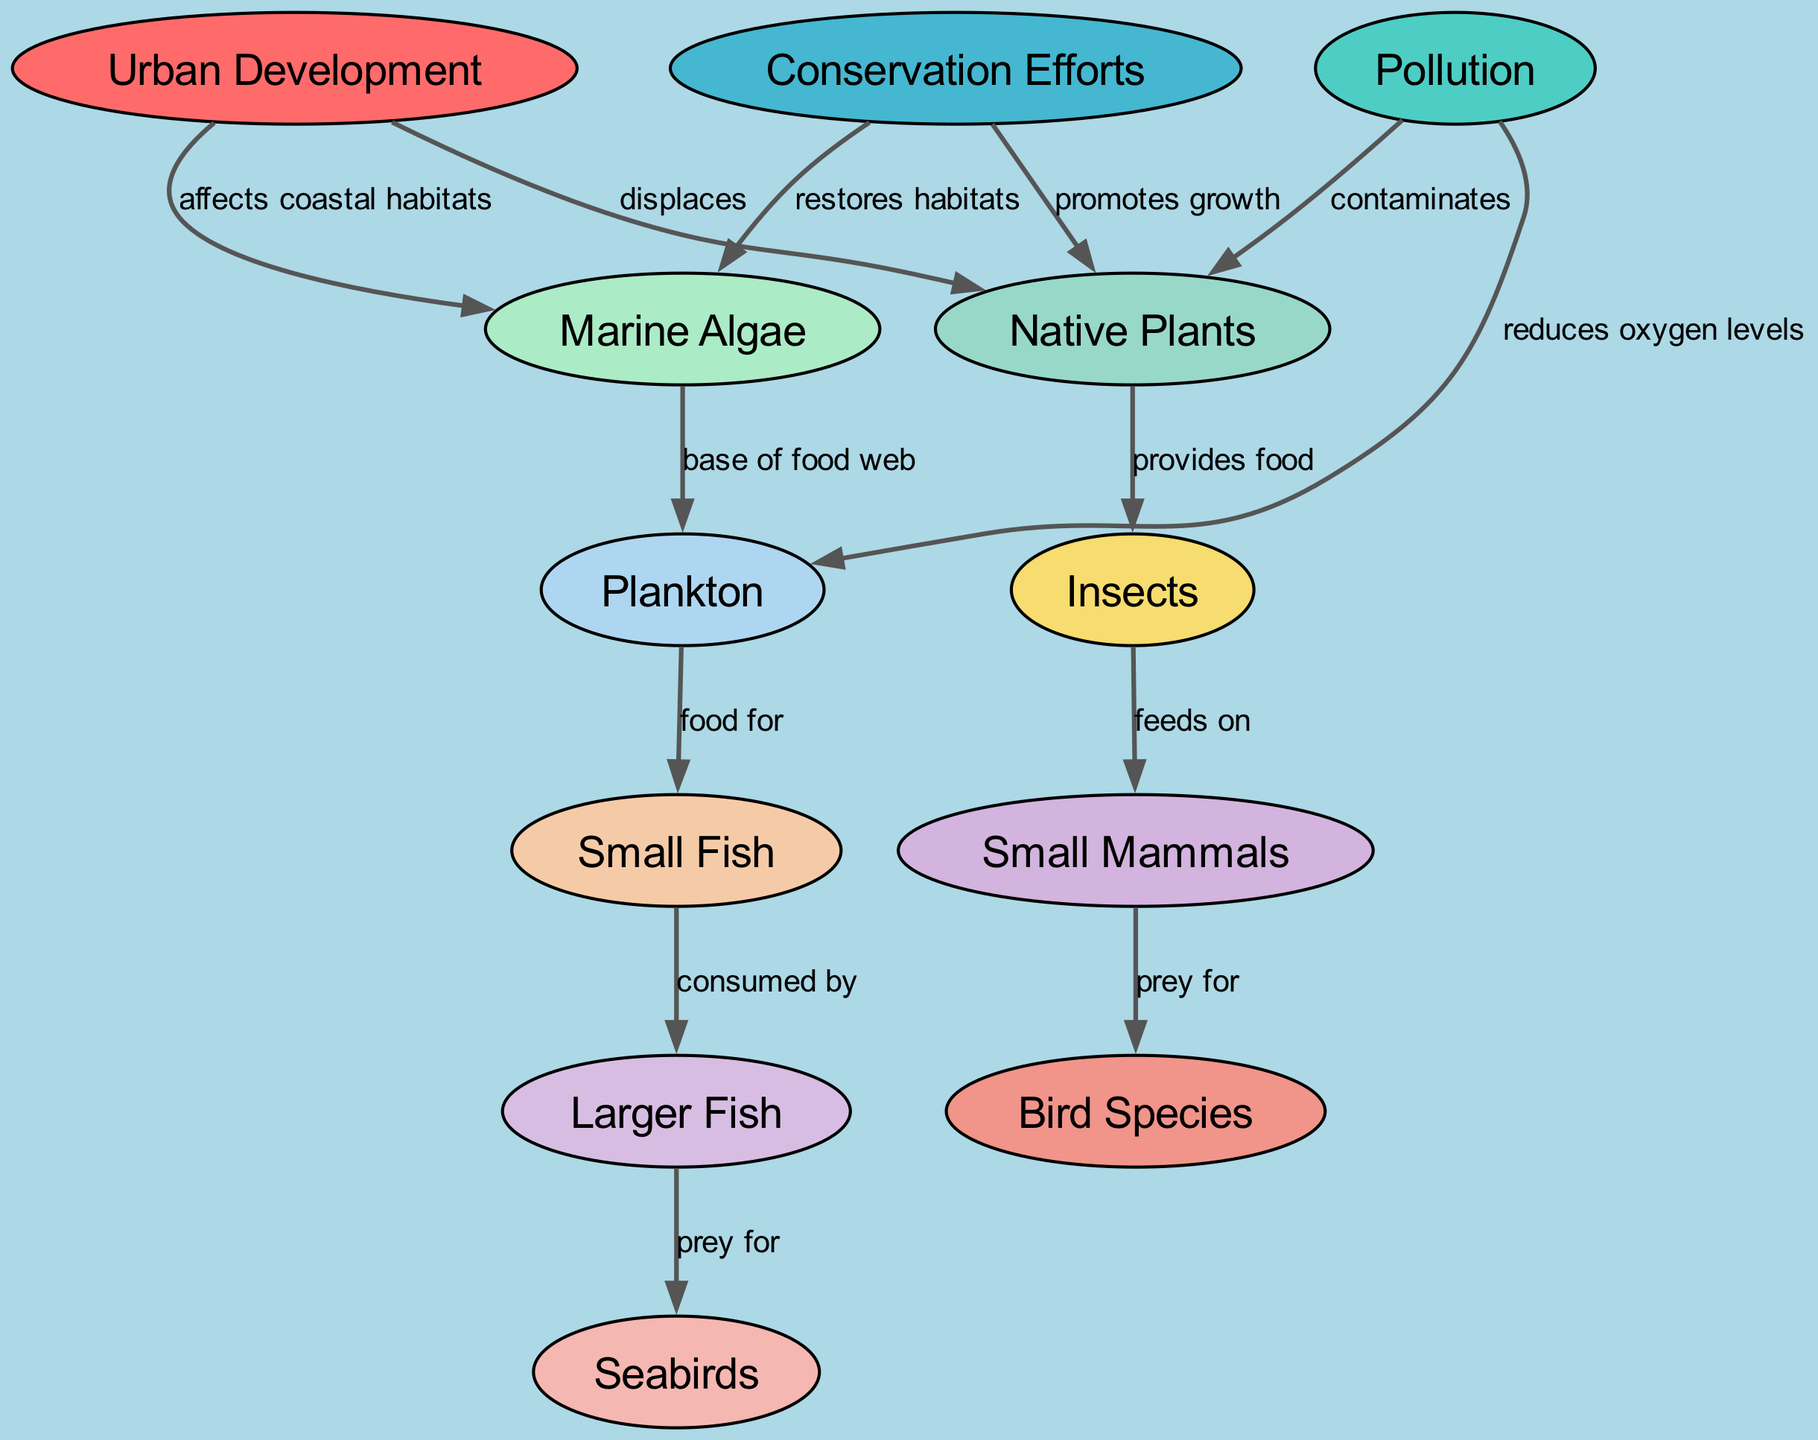What is the total number of nodes in the diagram? The diagram lists 12 nodes, which include Urban Development, Pollution, Conservation Efforts, Native Plants, Insects, Small Mammals, Bird Species, Marine Algae, Plankton, Small Fish, Larger Fish, and Seabirds.
Answer: 12 What effect does urban development have on native plants? The diagram states that urban development "displaces" native plants, meaning that as urban areas expand, native plants are pushed out of their natural habitats.
Answer: displaces Which two factors lead to the reduction of oxygen levels in the marine environment? The diagram indicates that pollution "reduces oxygen levels" and that urban development "affects coastal habitats," which indirectly is linked to marine conditions. Both pollution and urban development are connected to decreased oxygen.
Answer: Pollution and Urban Development What is the relationship between marine algae and plankton? According to the diagram, marine algae serve as the "base of food web," which means they are crucial for supporting plankton, providing them with food resources in the ecosystem.
Answer: base of food web How do conservation efforts impact native plants? The diagram shows that conservation efforts "promote growth" of native plants, suggesting that such efforts enhance the thriving of local flora by mitigating adverse human impacts.
Answer: promotes growth What type of species feeds on small mammals? The diagram illustrates that small mammals are "prey for" bird species, highlighting a direct predatory relationship within the terrestrial food chain.
Answer: Bird Species What kind of relationship exists between plankton and small fish? The edge connecting plankton and small fish indicates that plankton are "food for" small fish, establishing a feeding relationship necessary for small fish survival.
Answer: food for Which factors restore habitats according to the diagram? The diagram indicates that conservation efforts "restore habitats," helping to revive areas negatively impacted by urban development and pollution.
Answer: Conservation Efforts What do larger fish prey on? The diagram explicitly states that larger fish are "prey for" seabirds, outlining a food chain interaction where larger fish are consumed by a higher trophic level.
Answer: Seabirds 